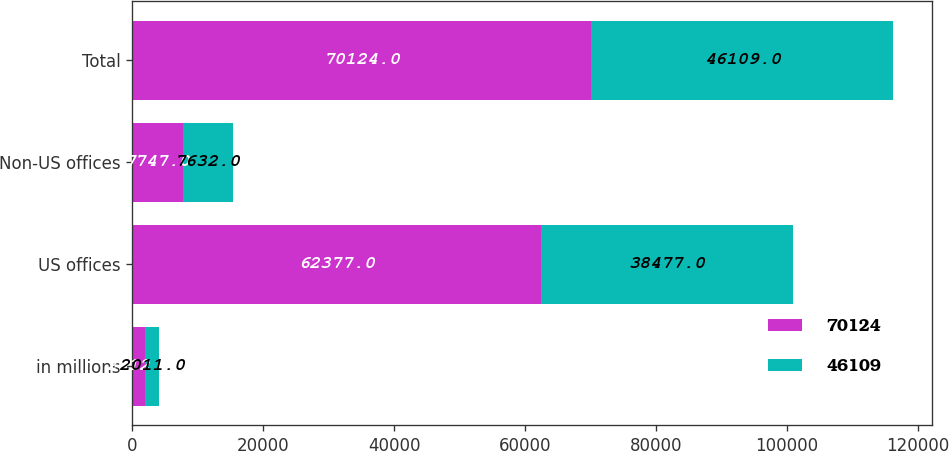Convert chart to OTSL. <chart><loc_0><loc_0><loc_500><loc_500><stacked_bar_chart><ecel><fcel>in millions<fcel>US offices<fcel>Non-US offices<fcel>Total<nl><fcel>70124<fcel>2012<fcel>62377<fcel>7747<fcel>70124<nl><fcel>46109<fcel>2011<fcel>38477<fcel>7632<fcel>46109<nl></chart> 